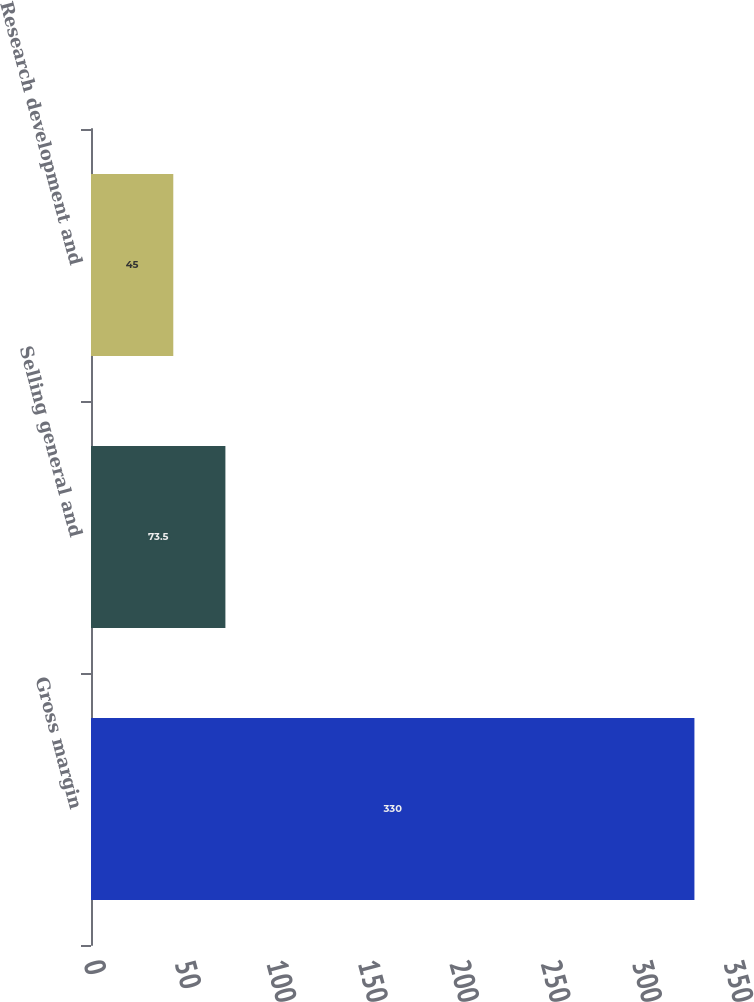Convert chart. <chart><loc_0><loc_0><loc_500><loc_500><bar_chart><fcel>Gross margin<fcel>Selling general and<fcel>Research development and<nl><fcel>330<fcel>73.5<fcel>45<nl></chart> 